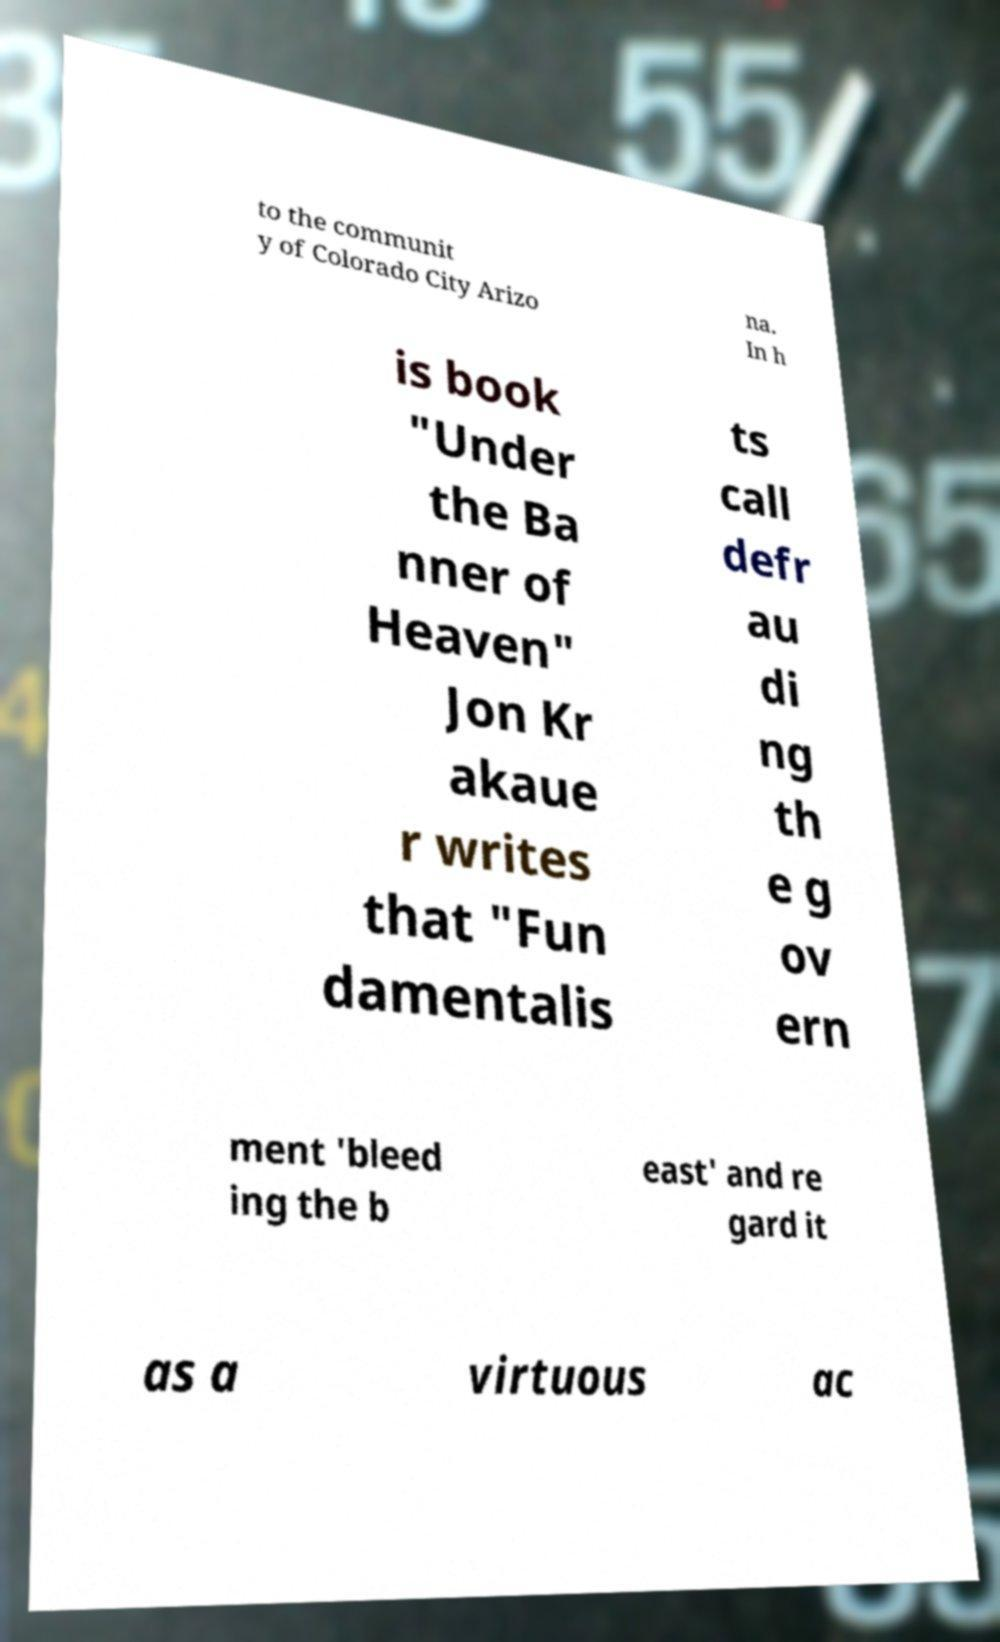For documentation purposes, I need the text within this image transcribed. Could you provide that? to the communit y of Colorado City Arizo na. In h is book "Under the Ba nner of Heaven" Jon Kr akaue r writes that "Fun damentalis ts call defr au di ng th e g ov ern ment 'bleed ing the b east' and re gard it as a virtuous ac 